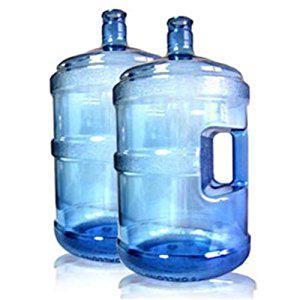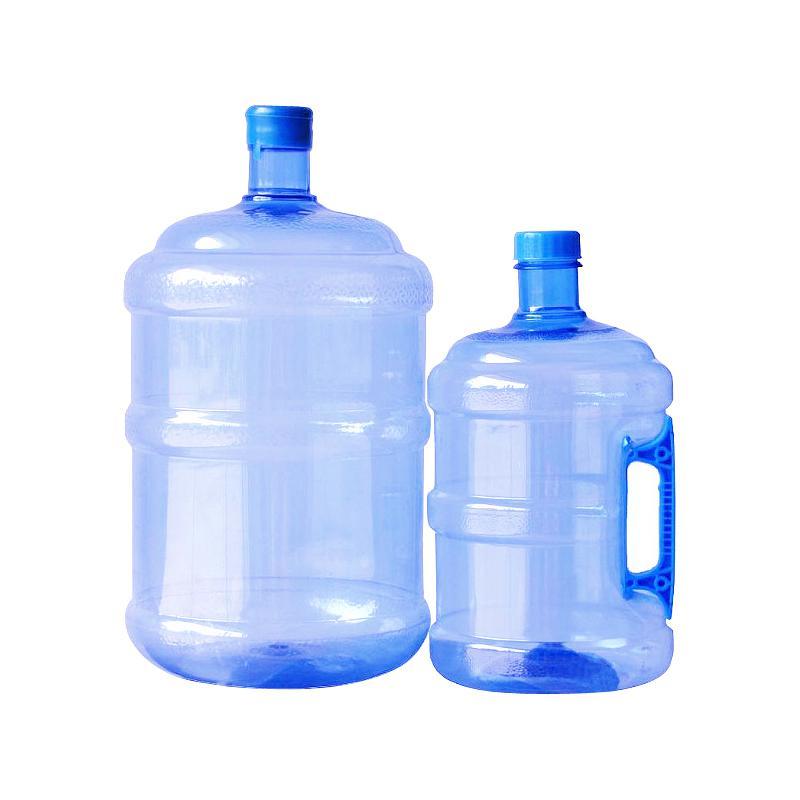The first image is the image on the left, the second image is the image on the right. Evaluate the accuracy of this statement regarding the images: "Exactly four blue tinted plastic bottles are shown, two with a hand grip in the side of the bottle, and two with no grips.". Is it true? Answer yes or no. Yes. 